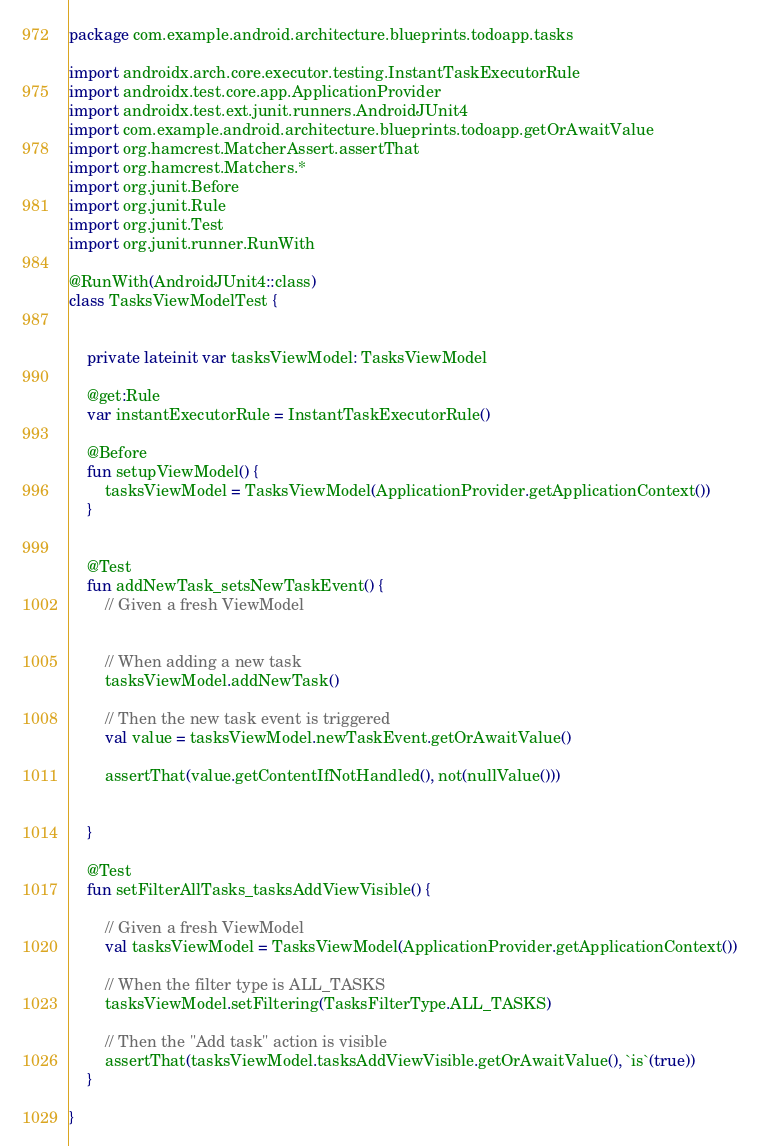Convert code to text. <code><loc_0><loc_0><loc_500><loc_500><_Kotlin_>package com.example.android.architecture.blueprints.todoapp.tasks

import androidx.arch.core.executor.testing.InstantTaskExecutorRule
import androidx.test.core.app.ApplicationProvider
import androidx.test.ext.junit.runners.AndroidJUnit4
import com.example.android.architecture.blueprints.todoapp.getOrAwaitValue
import org.hamcrest.MatcherAssert.assertThat
import org.hamcrest.Matchers.*
import org.junit.Before
import org.junit.Rule
import org.junit.Test
import org.junit.runner.RunWith

@RunWith(AndroidJUnit4::class)
class TasksViewModelTest {


    private lateinit var tasksViewModel: TasksViewModel

    @get:Rule
    var instantExecutorRule = InstantTaskExecutorRule()

    @Before
    fun setupViewModel() {
        tasksViewModel = TasksViewModel(ApplicationProvider.getApplicationContext())
    }


    @Test
    fun addNewTask_setsNewTaskEvent() {
        // Given a fresh ViewModel


        // When adding a new task
        tasksViewModel.addNewTask()

        // Then the new task event is triggered
        val value = tasksViewModel.newTaskEvent.getOrAwaitValue()

        assertThat(value.getContentIfNotHandled(), not(nullValue()))


    }

    @Test
    fun setFilterAllTasks_tasksAddViewVisible() {

        // Given a fresh ViewModel
        val tasksViewModel = TasksViewModel(ApplicationProvider.getApplicationContext())

        // When the filter type is ALL_TASKS
        tasksViewModel.setFiltering(TasksFilterType.ALL_TASKS)

        // Then the "Add task" action is visible
        assertThat(tasksViewModel.tasksAddViewVisible.getOrAwaitValue(), `is`(true))
    }

}</code> 